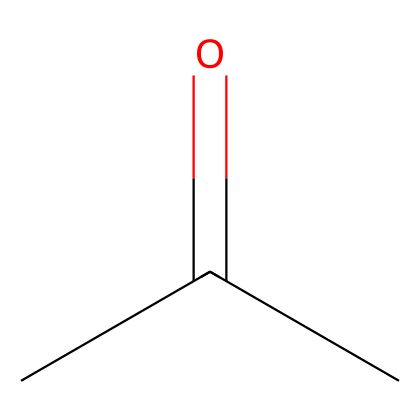What is the functional group present in this chemical? The structure contains a carbonyl group (C=O) at the end of the carbon chain, characteristic of aldehydes.
Answer: aldehyde How many carbon atoms are in this compound? Analyzing the SMILES representation, "CC(=O)C", indicates there are three carbon atoms connected in a chain.
Answer: three How many hydrogen atoms are bonded to the carbon atoms in this structure? In the given SMILES, two carbon atoms are bonded to three hydrogen atoms, and one carbon is doubly bonded to oxygen, resulting in a total of six hydrogen atoms.
Answer: six What is the simplest name for this aldehyde? The SMILES representation corresponds to propanal, which is the simplest name derived from its structure as an aldehyde with three carbon atoms.
Answer: propanal How many total bonds are present in this molecule? Counting the bonds from the SMILES structure, there are nine bonds in total: three C-C single bonds, one C=O double bond, and the remaining H bonds to carbon atoms.
Answer: nine What is the state of this aldehyde at room temperature? Aldehydes like propanal are usually found in a liquid state at room temperature due to their lower molecular weight and ability to form van der Waals interactions.
Answer: liquid Is this compound naturally occurring in cocoa butter? Yes, several aldehydes, including propanal, can occur naturally in fats and oils, including cocoa butter, contributing to flavor and aroma.
Answer: yes 